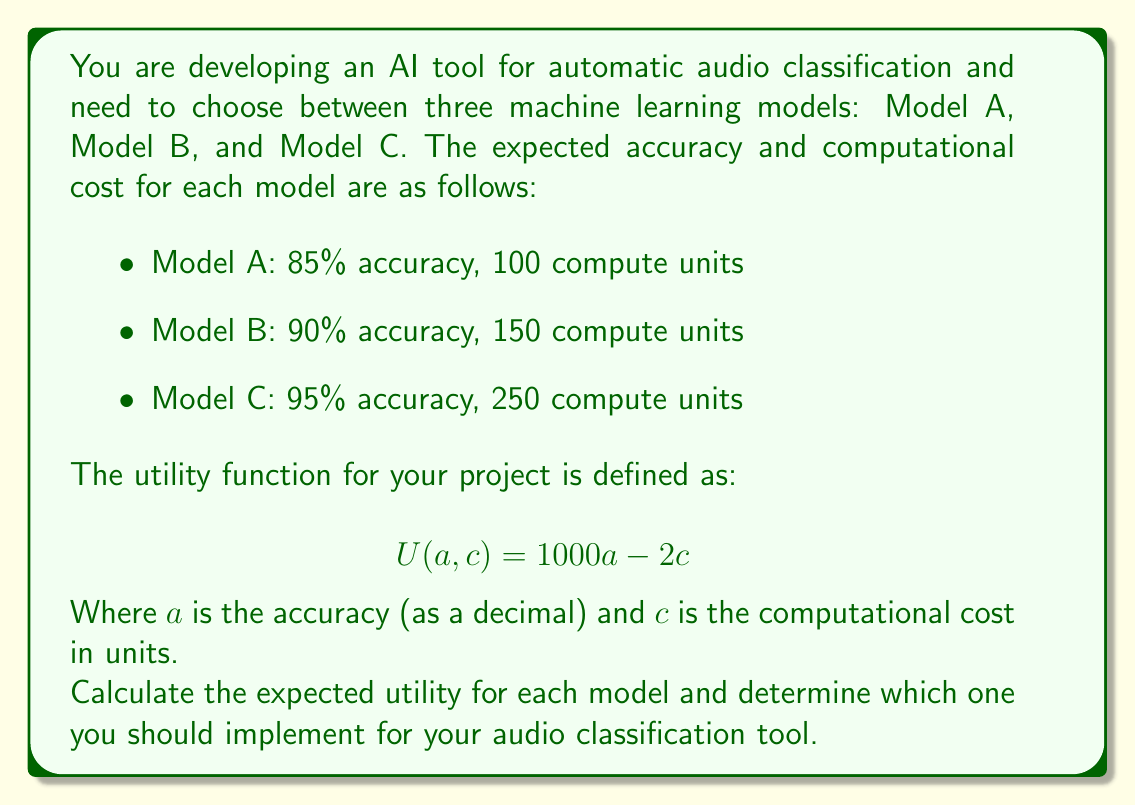Solve this math problem. To solve this problem, we need to calculate the utility for each model using the given utility function and then compare the results.

1. For Model A:
   Accuracy $a = 0.85$, Computational cost $c = 100$
   $$ U_A = 1000(0.85) - 2(100) = 850 - 200 = 650 $$

2. For Model B:
   Accuracy $a = 0.90$, Computational cost $c = 150$
   $$ U_B = 1000(0.90) - 2(150) = 900 - 300 = 600 $$

3. For Model C:
   Accuracy $a = 0.95$, Computational cost $c = 250$
   $$ U_C = 1000(0.95) - 2(250) = 950 - 500 = 450 $$

Now, we compare the utility values:
$$ U_A = 650 > U_B = 600 > U_C = 450 $$

Model A has the highest utility value, despite having the lowest accuracy. This is because the utility function balances the trade-off between accuracy and computational cost. The higher accuracy of Models B and C does not compensate for their increased computational costs in this case.
Answer: The expected utilities for each model are:
Model A: 650
Model B: 600
Model C: 450

You should implement Model A for your audio classification tool as it has the highest expected utility of 650. 